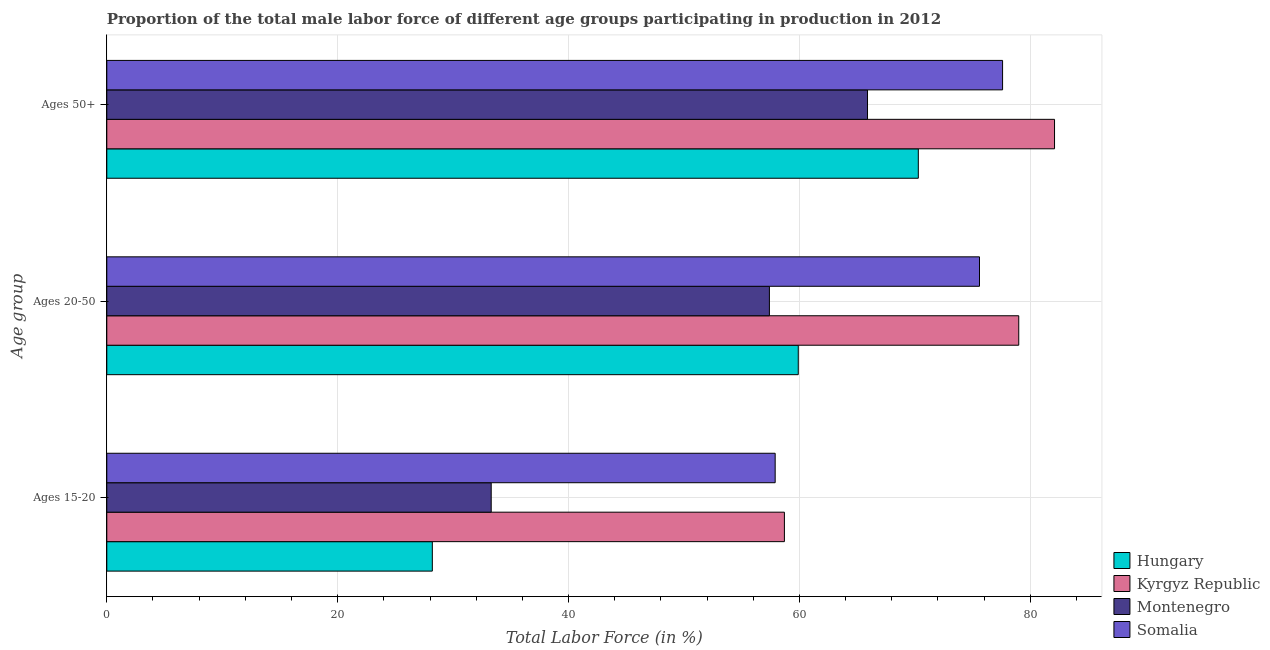Are the number of bars on each tick of the Y-axis equal?
Your answer should be very brief. Yes. How many bars are there on the 2nd tick from the bottom?
Give a very brief answer. 4. What is the label of the 1st group of bars from the top?
Offer a terse response. Ages 50+. What is the percentage of male labor force within the age group 15-20 in Somalia?
Offer a very short reply. 57.9. Across all countries, what is the maximum percentage of male labor force within the age group 20-50?
Provide a short and direct response. 79. Across all countries, what is the minimum percentage of male labor force within the age group 20-50?
Give a very brief answer. 57.4. In which country was the percentage of male labor force within the age group 20-50 maximum?
Offer a very short reply. Kyrgyz Republic. In which country was the percentage of male labor force within the age group 15-20 minimum?
Offer a terse response. Hungary. What is the total percentage of male labor force within the age group 20-50 in the graph?
Provide a succinct answer. 271.9. What is the difference between the percentage of male labor force within the age group 15-20 in Somalia and that in Hungary?
Offer a terse response. 29.7. What is the difference between the percentage of male labor force above age 50 in Kyrgyz Republic and the percentage of male labor force within the age group 20-50 in Hungary?
Provide a short and direct response. 22.2. What is the average percentage of male labor force within the age group 20-50 per country?
Offer a terse response. 67.98. What is the ratio of the percentage of male labor force within the age group 20-50 in Montenegro to that in Kyrgyz Republic?
Your answer should be compact. 0.73. What is the difference between the highest and the second highest percentage of male labor force within the age group 15-20?
Your answer should be compact. 0.8. What is the difference between the highest and the lowest percentage of male labor force within the age group 15-20?
Your response must be concise. 30.5. What does the 1st bar from the top in Ages 50+ represents?
Your response must be concise. Somalia. What does the 1st bar from the bottom in Ages 50+ represents?
Your response must be concise. Hungary. Is it the case that in every country, the sum of the percentage of male labor force within the age group 15-20 and percentage of male labor force within the age group 20-50 is greater than the percentage of male labor force above age 50?
Your response must be concise. Yes. Are all the bars in the graph horizontal?
Offer a very short reply. Yes. What is the difference between two consecutive major ticks on the X-axis?
Provide a short and direct response. 20. Does the graph contain any zero values?
Ensure brevity in your answer.  No. Does the graph contain grids?
Your answer should be very brief. Yes. Where does the legend appear in the graph?
Offer a terse response. Bottom right. How are the legend labels stacked?
Provide a short and direct response. Vertical. What is the title of the graph?
Your response must be concise. Proportion of the total male labor force of different age groups participating in production in 2012. What is the label or title of the X-axis?
Your answer should be very brief. Total Labor Force (in %). What is the label or title of the Y-axis?
Provide a succinct answer. Age group. What is the Total Labor Force (in %) of Hungary in Ages 15-20?
Your answer should be very brief. 28.2. What is the Total Labor Force (in %) in Kyrgyz Republic in Ages 15-20?
Provide a succinct answer. 58.7. What is the Total Labor Force (in %) in Montenegro in Ages 15-20?
Offer a very short reply. 33.3. What is the Total Labor Force (in %) in Somalia in Ages 15-20?
Provide a succinct answer. 57.9. What is the Total Labor Force (in %) of Hungary in Ages 20-50?
Ensure brevity in your answer.  59.9. What is the Total Labor Force (in %) of Kyrgyz Republic in Ages 20-50?
Your answer should be compact. 79. What is the Total Labor Force (in %) in Montenegro in Ages 20-50?
Keep it short and to the point. 57.4. What is the Total Labor Force (in %) in Somalia in Ages 20-50?
Your response must be concise. 75.6. What is the Total Labor Force (in %) of Hungary in Ages 50+?
Offer a terse response. 70.3. What is the Total Labor Force (in %) in Kyrgyz Republic in Ages 50+?
Keep it short and to the point. 82.1. What is the Total Labor Force (in %) in Montenegro in Ages 50+?
Provide a succinct answer. 65.9. What is the Total Labor Force (in %) in Somalia in Ages 50+?
Ensure brevity in your answer.  77.6. Across all Age group, what is the maximum Total Labor Force (in %) of Hungary?
Provide a short and direct response. 70.3. Across all Age group, what is the maximum Total Labor Force (in %) in Kyrgyz Republic?
Give a very brief answer. 82.1. Across all Age group, what is the maximum Total Labor Force (in %) in Montenegro?
Provide a short and direct response. 65.9. Across all Age group, what is the maximum Total Labor Force (in %) of Somalia?
Offer a very short reply. 77.6. Across all Age group, what is the minimum Total Labor Force (in %) in Hungary?
Offer a very short reply. 28.2. Across all Age group, what is the minimum Total Labor Force (in %) of Kyrgyz Republic?
Give a very brief answer. 58.7. Across all Age group, what is the minimum Total Labor Force (in %) in Montenegro?
Provide a short and direct response. 33.3. Across all Age group, what is the minimum Total Labor Force (in %) of Somalia?
Provide a succinct answer. 57.9. What is the total Total Labor Force (in %) of Hungary in the graph?
Offer a very short reply. 158.4. What is the total Total Labor Force (in %) of Kyrgyz Republic in the graph?
Your answer should be very brief. 219.8. What is the total Total Labor Force (in %) in Montenegro in the graph?
Give a very brief answer. 156.6. What is the total Total Labor Force (in %) of Somalia in the graph?
Offer a very short reply. 211.1. What is the difference between the Total Labor Force (in %) of Hungary in Ages 15-20 and that in Ages 20-50?
Keep it short and to the point. -31.7. What is the difference between the Total Labor Force (in %) in Kyrgyz Republic in Ages 15-20 and that in Ages 20-50?
Your answer should be compact. -20.3. What is the difference between the Total Labor Force (in %) in Montenegro in Ages 15-20 and that in Ages 20-50?
Make the answer very short. -24.1. What is the difference between the Total Labor Force (in %) in Somalia in Ages 15-20 and that in Ages 20-50?
Offer a very short reply. -17.7. What is the difference between the Total Labor Force (in %) of Hungary in Ages 15-20 and that in Ages 50+?
Offer a terse response. -42.1. What is the difference between the Total Labor Force (in %) in Kyrgyz Republic in Ages 15-20 and that in Ages 50+?
Keep it short and to the point. -23.4. What is the difference between the Total Labor Force (in %) of Montenegro in Ages 15-20 and that in Ages 50+?
Ensure brevity in your answer.  -32.6. What is the difference between the Total Labor Force (in %) in Somalia in Ages 15-20 and that in Ages 50+?
Your answer should be very brief. -19.7. What is the difference between the Total Labor Force (in %) of Hungary in Ages 20-50 and that in Ages 50+?
Offer a terse response. -10.4. What is the difference between the Total Labor Force (in %) in Kyrgyz Republic in Ages 20-50 and that in Ages 50+?
Make the answer very short. -3.1. What is the difference between the Total Labor Force (in %) of Montenegro in Ages 20-50 and that in Ages 50+?
Provide a short and direct response. -8.5. What is the difference between the Total Labor Force (in %) of Somalia in Ages 20-50 and that in Ages 50+?
Give a very brief answer. -2. What is the difference between the Total Labor Force (in %) in Hungary in Ages 15-20 and the Total Labor Force (in %) in Kyrgyz Republic in Ages 20-50?
Your response must be concise. -50.8. What is the difference between the Total Labor Force (in %) in Hungary in Ages 15-20 and the Total Labor Force (in %) in Montenegro in Ages 20-50?
Offer a terse response. -29.2. What is the difference between the Total Labor Force (in %) in Hungary in Ages 15-20 and the Total Labor Force (in %) in Somalia in Ages 20-50?
Provide a succinct answer. -47.4. What is the difference between the Total Labor Force (in %) in Kyrgyz Republic in Ages 15-20 and the Total Labor Force (in %) in Montenegro in Ages 20-50?
Give a very brief answer. 1.3. What is the difference between the Total Labor Force (in %) in Kyrgyz Republic in Ages 15-20 and the Total Labor Force (in %) in Somalia in Ages 20-50?
Offer a very short reply. -16.9. What is the difference between the Total Labor Force (in %) in Montenegro in Ages 15-20 and the Total Labor Force (in %) in Somalia in Ages 20-50?
Ensure brevity in your answer.  -42.3. What is the difference between the Total Labor Force (in %) in Hungary in Ages 15-20 and the Total Labor Force (in %) in Kyrgyz Republic in Ages 50+?
Your answer should be very brief. -53.9. What is the difference between the Total Labor Force (in %) in Hungary in Ages 15-20 and the Total Labor Force (in %) in Montenegro in Ages 50+?
Offer a terse response. -37.7. What is the difference between the Total Labor Force (in %) in Hungary in Ages 15-20 and the Total Labor Force (in %) in Somalia in Ages 50+?
Your answer should be very brief. -49.4. What is the difference between the Total Labor Force (in %) of Kyrgyz Republic in Ages 15-20 and the Total Labor Force (in %) of Montenegro in Ages 50+?
Your answer should be very brief. -7.2. What is the difference between the Total Labor Force (in %) of Kyrgyz Republic in Ages 15-20 and the Total Labor Force (in %) of Somalia in Ages 50+?
Offer a terse response. -18.9. What is the difference between the Total Labor Force (in %) in Montenegro in Ages 15-20 and the Total Labor Force (in %) in Somalia in Ages 50+?
Make the answer very short. -44.3. What is the difference between the Total Labor Force (in %) of Hungary in Ages 20-50 and the Total Labor Force (in %) of Kyrgyz Republic in Ages 50+?
Provide a short and direct response. -22.2. What is the difference between the Total Labor Force (in %) of Hungary in Ages 20-50 and the Total Labor Force (in %) of Somalia in Ages 50+?
Provide a short and direct response. -17.7. What is the difference between the Total Labor Force (in %) of Kyrgyz Republic in Ages 20-50 and the Total Labor Force (in %) of Somalia in Ages 50+?
Your answer should be very brief. 1.4. What is the difference between the Total Labor Force (in %) of Montenegro in Ages 20-50 and the Total Labor Force (in %) of Somalia in Ages 50+?
Provide a succinct answer. -20.2. What is the average Total Labor Force (in %) in Hungary per Age group?
Offer a terse response. 52.8. What is the average Total Labor Force (in %) of Kyrgyz Republic per Age group?
Your answer should be compact. 73.27. What is the average Total Labor Force (in %) of Montenegro per Age group?
Offer a very short reply. 52.2. What is the average Total Labor Force (in %) of Somalia per Age group?
Your response must be concise. 70.37. What is the difference between the Total Labor Force (in %) of Hungary and Total Labor Force (in %) of Kyrgyz Republic in Ages 15-20?
Give a very brief answer. -30.5. What is the difference between the Total Labor Force (in %) of Hungary and Total Labor Force (in %) of Montenegro in Ages 15-20?
Give a very brief answer. -5.1. What is the difference between the Total Labor Force (in %) in Hungary and Total Labor Force (in %) in Somalia in Ages 15-20?
Your answer should be very brief. -29.7. What is the difference between the Total Labor Force (in %) in Kyrgyz Republic and Total Labor Force (in %) in Montenegro in Ages 15-20?
Keep it short and to the point. 25.4. What is the difference between the Total Labor Force (in %) in Montenegro and Total Labor Force (in %) in Somalia in Ages 15-20?
Your answer should be compact. -24.6. What is the difference between the Total Labor Force (in %) of Hungary and Total Labor Force (in %) of Kyrgyz Republic in Ages 20-50?
Offer a terse response. -19.1. What is the difference between the Total Labor Force (in %) of Hungary and Total Labor Force (in %) of Montenegro in Ages 20-50?
Give a very brief answer. 2.5. What is the difference between the Total Labor Force (in %) in Hungary and Total Labor Force (in %) in Somalia in Ages 20-50?
Offer a terse response. -15.7. What is the difference between the Total Labor Force (in %) in Kyrgyz Republic and Total Labor Force (in %) in Montenegro in Ages 20-50?
Your answer should be compact. 21.6. What is the difference between the Total Labor Force (in %) of Montenegro and Total Labor Force (in %) of Somalia in Ages 20-50?
Your answer should be very brief. -18.2. What is the difference between the Total Labor Force (in %) in Hungary and Total Labor Force (in %) in Montenegro in Ages 50+?
Ensure brevity in your answer.  4.4. What is the difference between the Total Labor Force (in %) of Hungary and Total Labor Force (in %) of Somalia in Ages 50+?
Your answer should be very brief. -7.3. What is the difference between the Total Labor Force (in %) in Kyrgyz Republic and Total Labor Force (in %) in Montenegro in Ages 50+?
Ensure brevity in your answer.  16.2. What is the ratio of the Total Labor Force (in %) of Hungary in Ages 15-20 to that in Ages 20-50?
Provide a short and direct response. 0.47. What is the ratio of the Total Labor Force (in %) of Kyrgyz Republic in Ages 15-20 to that in Ages 20-50?
Provide a short and direct response. 0.74. What is the ratio of the Total Labor Force (in %) of Montenegro in Ages 15-20 to that in Ages 20-50?
Your response must be concise. 0.58. What is the ratio of the Total Labor Force (in %) in Somalia in Ages 15-20 to that in Ages 20-50?
Offer a terse response. 0.77. What is the ratio of the Total Labor Force (in %) of Hungary in Ages 15-20 to that in Ages 50+?
Offer a very short reply. 0.4. What is the ratio of the Total Labor Force (in %) of Kyrgyz Republic in Ages 15-20 to that in Ages 50+?
Offer a very short reply. 0.71. What is the ratio of the Total Labor Force (in %) in Montenegro in Ages 15-20 to that in Ages 50+?
Your response must be concise. 0.51. What is the ratio of the Total Labor Force (in %) in Somalia in Ages 15-20 to that in Ages 50+?
Make the answer very short. 0.75. What is the ratio of the Total Labor Force (in %) of Hungary in Ages 20-50 to that in Ages 50+?
Your answer should be very brief. 0.85. What is the ratio of the Total Labor Force (in %) in Kyrgyz Republic in Ages 20-50 to that in Ages 50+?
Your response must be concise. 0.96. What is the ratio of the Total Labor Force (in %) of Montenegro in Ages 20-50 to that in Ages 50+?
Your answer should be compact. 0.87. What is the ratio of the Total Labor Force (in %) of Somalia in Ages 20-50 to that in Ages 50+?
Offer a terse response. 0.97. What is the difference between the highest and the second highest Total Labor Force (in %) of Hungary?
Ensure brevity in your answer.  10.4. What is the difference between the highest and the second highest Total Labor Force (in %) of Kyrgyz Republic?
Make the answer very short. 3.1. What is the difference between the highest and the second highest Total Labor Force (in %) in Somalia?
Your answer should be compact. 2. What is the difference between the highest and the lowest Total Labor Force (in %) in Hungary?
Your answer should be compact. 42.1. What is the difference between the highest and the lowest Total Labor Force (in %) in Kyrgyz Republic?
Your answer should be compact. 23.4. What is the difference between the highest and the lowest Total Labor Force (in %) in Montenegro?
Ensure brevity in your answer.  32.6. 